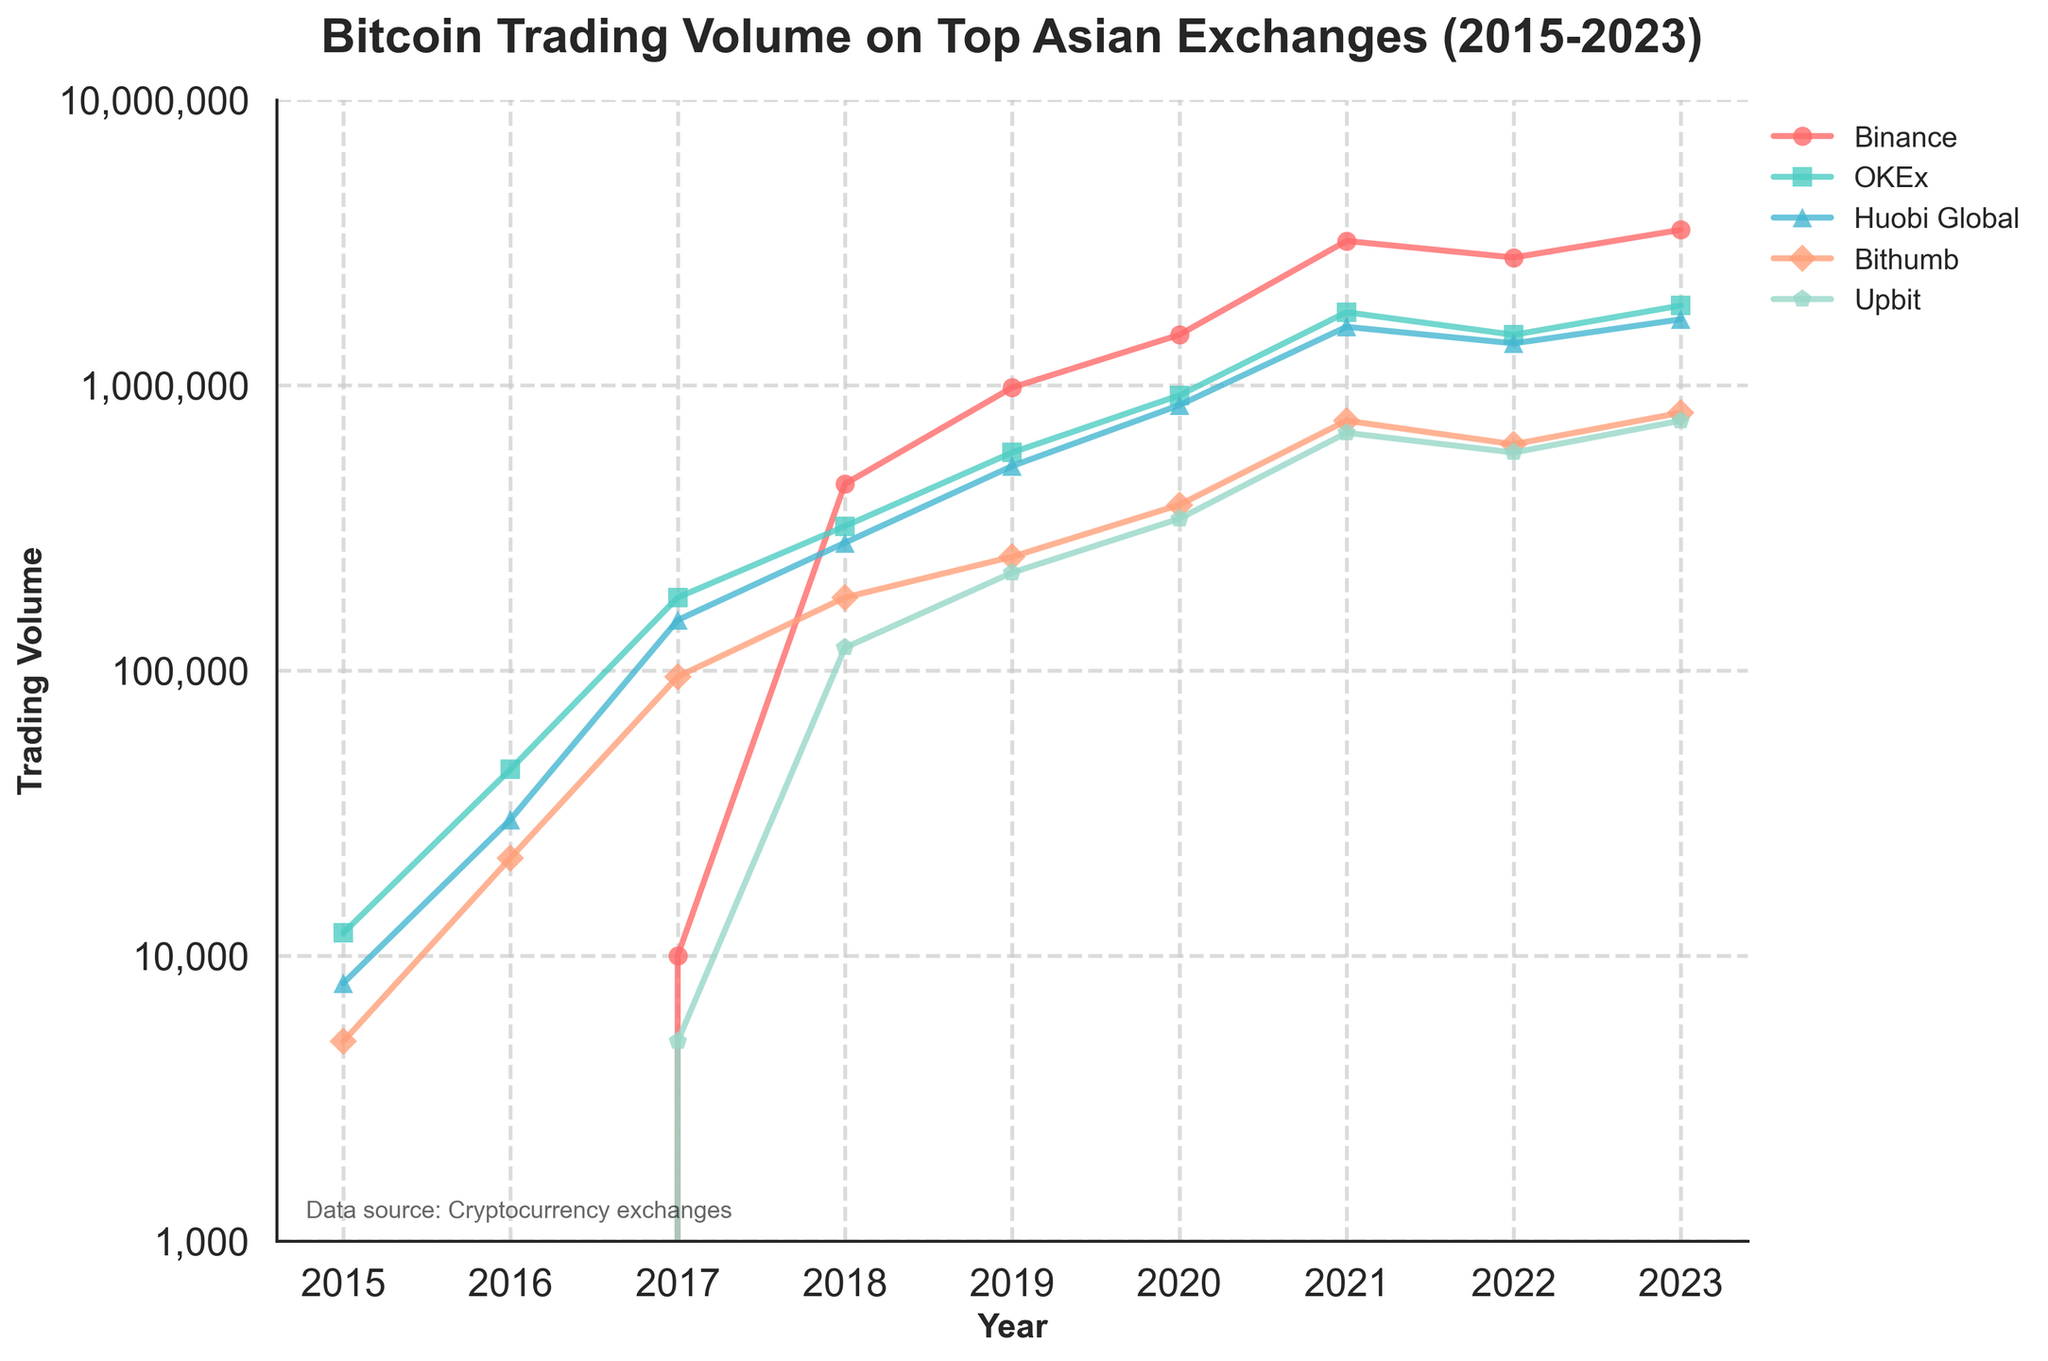What year did Binance first emerge in the dataset with a trading volume? Binance first appears in the dataset in 2017 with a trading volume of 10,000. This is the first instance of Binance having recorded trading volume in the given data.
Answer: 2017 Which exchange had the highest trading volume in 2020, and what was that volume? By examining the 2020 data points, Binance had the highest trading volume at 1,500,000, which is the maximum value among the exchanges listed for that year.
Answer: Binance with 1,500,000 How did the trading volume on OKEx change from 2018 to 2019? In 2018, the trading volume on OKEx was 320,000. By 2019, it had increased to 580,000. The change is calculated as 580,000 - 320,000 = 260,000.
Answer: Increased by 260,000 Which exchange shows the most consistent growth in trading volume from 2015 to 2023? Binance exhibits the most consistent growth with its trading volume increasing steadily from 2017 and continuing to rise each year, reaching the highest value in 2023 at 3,500,000.
Answer: Binance Compare the trading volume between Huobi Global and Upbit in 2021. Which one had more and by how much? In 2021, Huobi Global had a trading volume of 1,600,000 while Upbit had 680,000. The difference is calculated as 1,600,000 - 680,000 = 920,000. Thus, Huobi Global had 920,000 more in trading volume.
Answer: Huobi Global, 920,000 Identify the first year when Upbit showed a trading volume in the dataset. What was the volume that year? Upbit first appears in the dataset in 2017 with a trading volume of 5,000.
Answer: 2017 Considering Bithumb and Upbit, which exchange experienced a greater increase in trading volume from 2019 to 2020? By how much? In 2019, Bithumb had 250,000 and Upbit had 220,000. By 2020, Bithumb had 380,000 and Upbit had 340,000. The changes are 380,000 - 250,000 = 130,000 for Bithumb and 340,000 - 220,000 = 120,000 for Upbit. Bithumb experienced a greater increase by 10,000.
Answer: Bithumb by 10,000 Across all exchanges, which year witnessed the highest total trading volume? By adding up the trading volumes for each year, it is clear that 2023 had the highest total trading volume: 3,500,000 (Binance) + 1,900,000 (OKEx) + 1,700,000 (Huobi Global) + 800,000 (Bithumb) + 750,000 (Upbit) = 8,650,000.
Answer: 2023 Which year did Huobi Global reach its peak trading volume according to the figure? Huobi Global reached its peak trading volume in 2019 with a value of 2,800,000.
Answer: 2019 What’s the difference in trading volume between the highest and lowest trading volumes recorded in 2021 among all exchanges? In 2021, the highest trading volume was Binance with 3,200,000 and the lowest was Upbit with 680,000. The difference is calculated as 3,200,000 - 680,000 = 2,520,000.
Answer: 2,520,000 